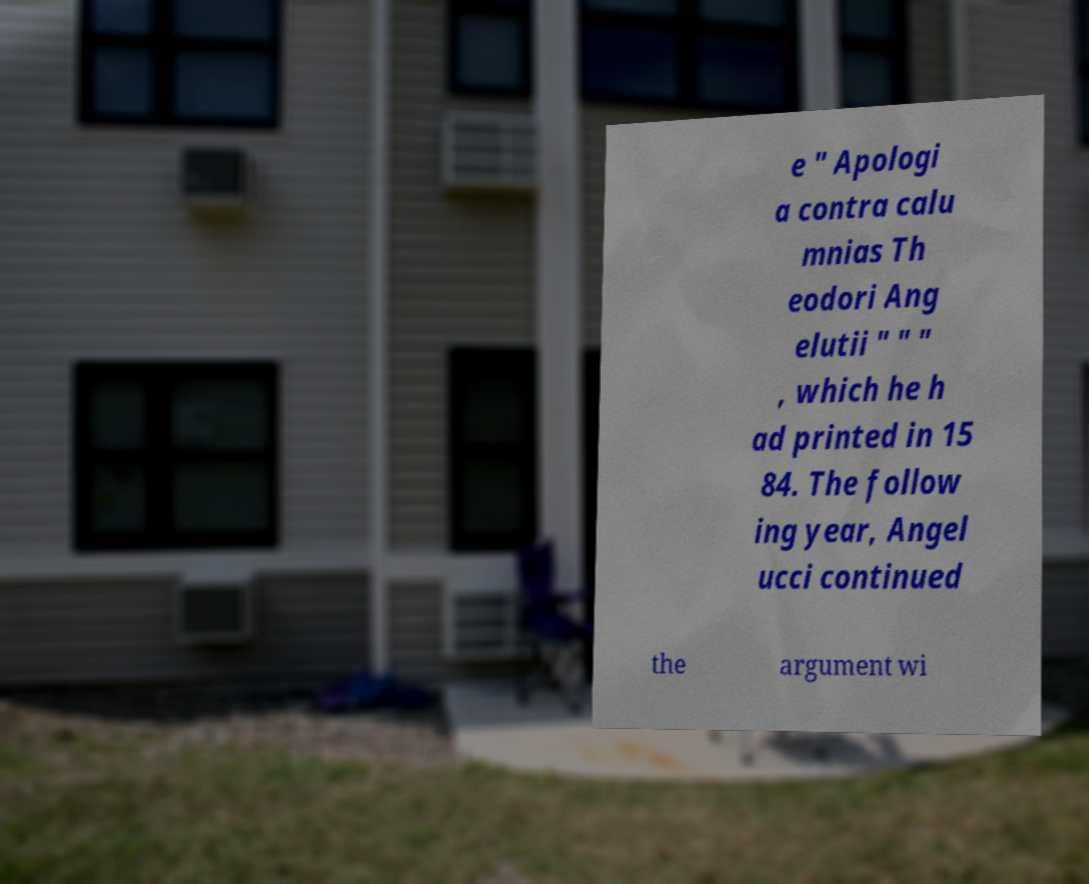Could you assist in decoding the text presented in this image and type it out clearly? e " Apologi a contra calu mnias Th eodori Ang elutii " " " , which he h ad printed in 15 84. The follow ing year, Angel ucci continued the argument wi 